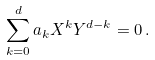<formula> <loc_0><loc_0><loc_500><loc_500>\sum _ { k = 0 } ^ { d } a _ { k } X ^ { k } Y ^ { d - k } = 0 \, .</formula> 